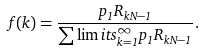<formula> <loc_0><loc_0><loc_500><loc_500>f ( k ) = \frac { p _ { 1 } R _ { k N - 1 } } { \sum \lim i t s _ { k = 1 } ^ { \infty } p _ { 1 } R _ { k N - 1 } } .</formula> 